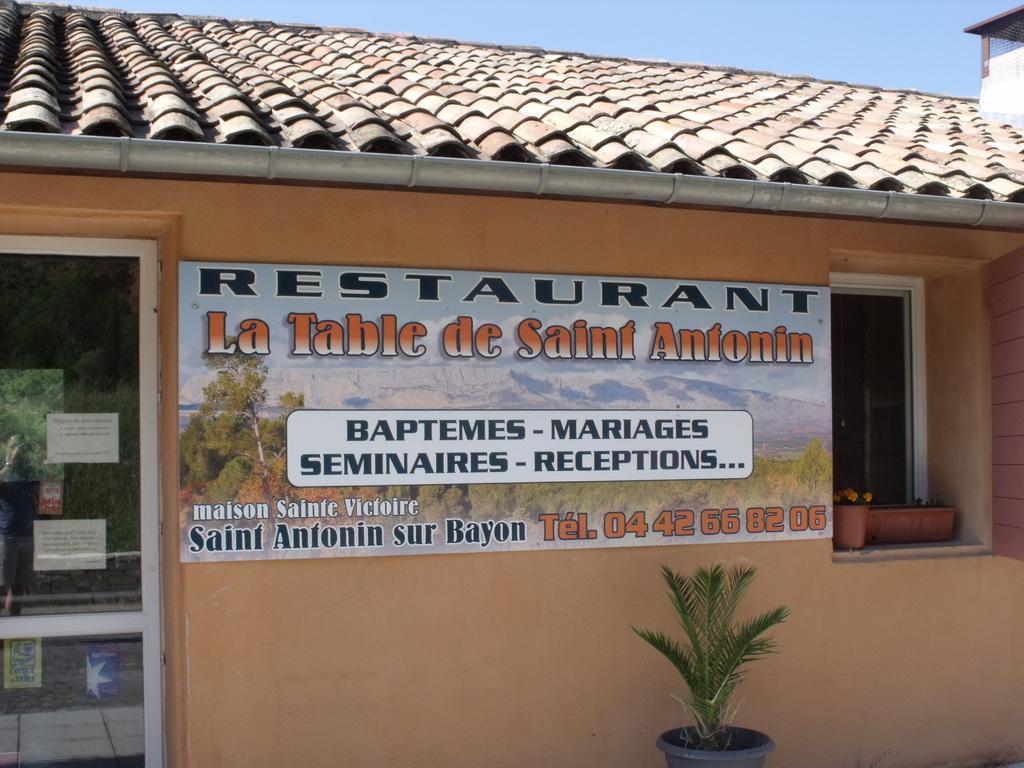In one or two sentences, can you explain what this image depicts? In this picture there is a restaurant in the center of the image and there is a door on the left side of the image and there is a poster in the center of the image, there is a window on the right side of the image and there is a plant at the bottom side of the image. 